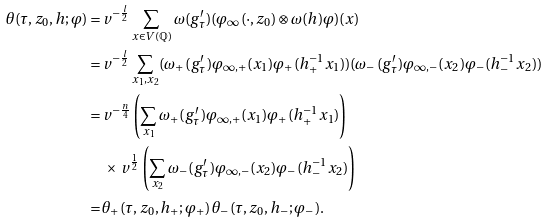Convert formula to latex. <formula><loc_0><loc_0><loc_500><loc_500>\theta ( \tau , z _ { 0 } , h ; \varphi ) = \, & v ^ { - \frac { l } { 2 } } \sum _ { x \in V ( \mathbb { Q } ) } \omega ( g ^ { \prime } _ { \tau } ) ( \varphi _ { \infty } ( \cdot , z _ { 0 } ) \otimes \omega ( h ) \varphi ) ( x ) \\ = \, & v ^ { - \frac { l } { 2 } } \sum _ { x _ { 1 } , x _ { 2 } } ( \omega _ { + } ( g ^ { \prime } _ { \tau } ) \varphi _ { \infty , + } ( x _ { 1 } ) \varphi _ { + } ( h _ { + } ^ { - 1 } x _ { 1 } ) ) ( \omega _ { - } ( g ^ { \prime } _ { \tau } ) \varphi _ { \infty , - } ( x _ { 2 } ) \varphi _ { - } ( h _ { - } ^ { - 1 } x _ { 2 } ) ) \\ = \, & v ^ { - \frac { n } { 4 } } \left ( \sum _ { x _ { 1 } } \omega _ { + } ( g ^ { \prime } _ { \tau } ) \varphi _ { \infty , + } ( x _ { 1 } ) \varphi _ { + } ( h _ { + } ^ { - 1 } x _ { 1 } ) \right ) \\ & \, \times \, v ^ { \frac { 1 } { 2 } } \left ( \sum _ { x _ { 2 } } \omega _ { - } ( g ^ { \prime } _ { \tau } ) \varphi _ { \infty , - } ( x _ { 2 } ) \varphi _ { - } ( h _ { - } ^ { - 1 } x _ { 2 } ) \right ) \\ = \, & \theta _ { + } ( \tau , z _ { 0 } , h _ { + } ; \varphi _ { + } ) \, \theta _ { - } ( \tau , z _ { 0 } , h _ { - } ; \varphi _ { - } ) .</formula> 